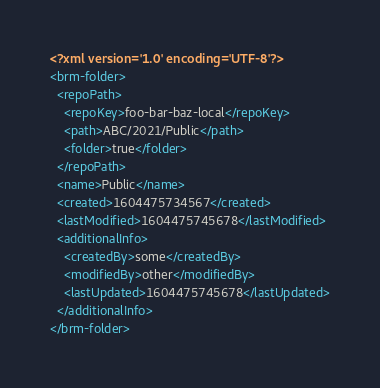<code> <loc_0><loc_0><loc_500><loc_500><_XML_><?xml version='1.0' encoding='UTF-8'?>
<brm-folder>
  <repoPath>
    <repoKey>foo-bar-baz-local</repoKey>
    <path>ABC/2021/Public</path>
    <folder>true</folder>
  </repoPath>
  <name>Public</name>
  <created>1604475734567</created>
  <lastModified>1604475745678</lastModified>
  <additionalInfo>
    <createdBy>some</createdBy>
    <modifiedBy>other</modifiedBy>
    <lastUpdated>1604475745678</lastUpdated>
  </additionalInfo>
</brm-folder>
</code> 